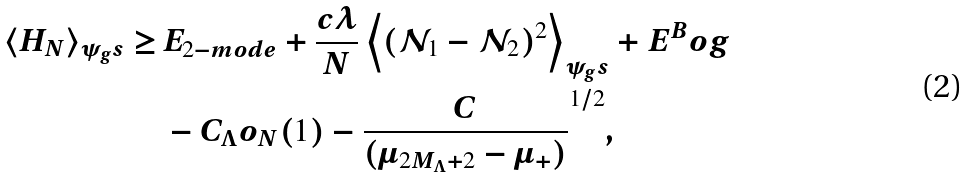Convert formula to latex. <formula><loc_0><loc_0><loc_500><loc_500>\langle H _ { N } \rangle _ { \psi _ { g } s } \geq \, & E _ { 2 - m o d e } + \frac { c \lambda } { N } \left \langle ( \mathcal { N } _ { 1 } - \mathcal { N } _ { 2 } ) ^ { 2 } \right \rangle _ { \psi _ { g } s } + E ^ { B } o g \\ & - C _ { \Lambda } o _ { N } ( 1 ) - \frac { C } { ( \mu _ { 2 M _ { \Lambda } + 2 } - \mu _ { + } ) } ^ { 1 / 2 } ,</formula> 